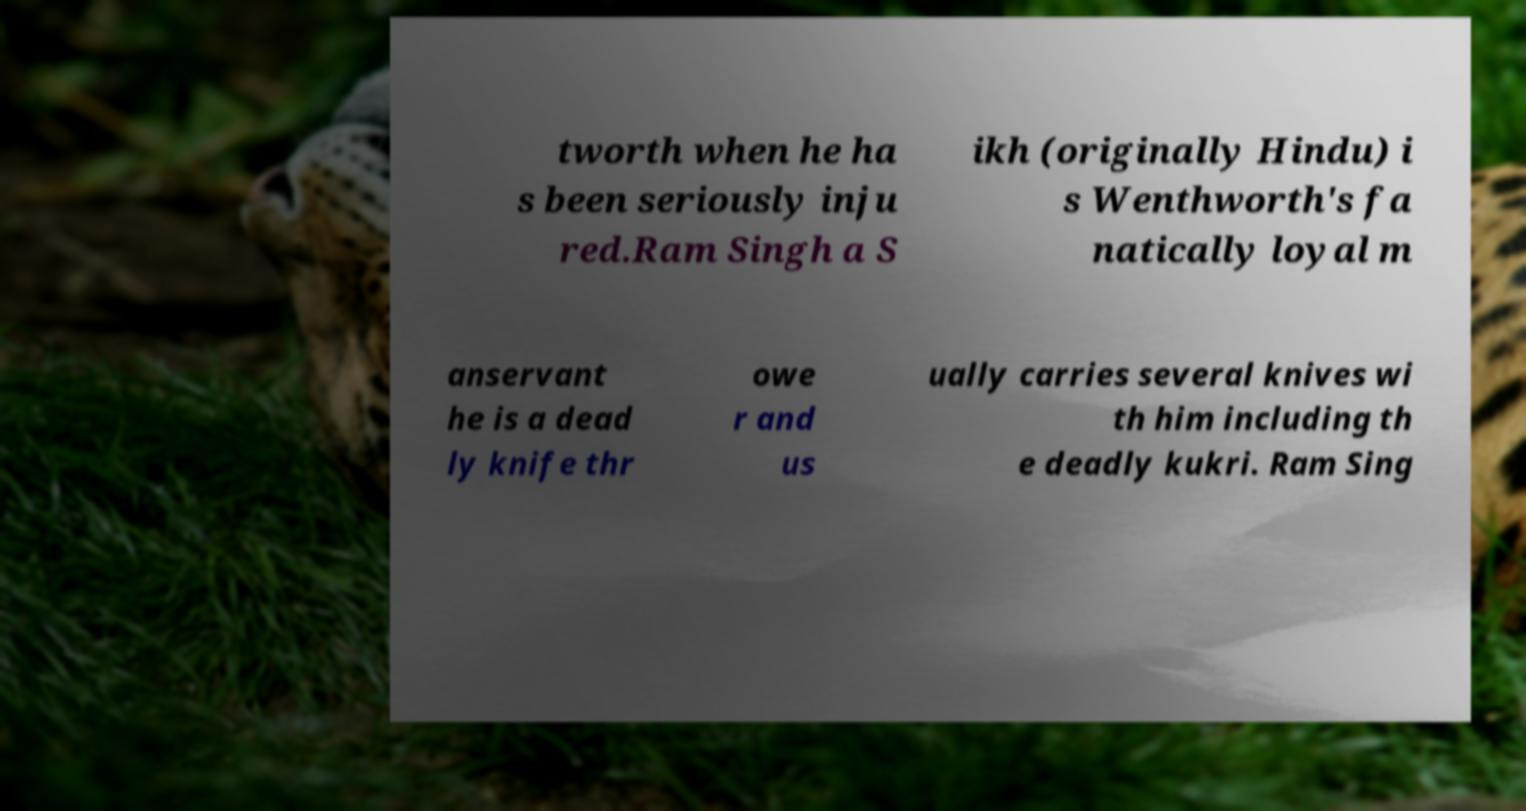For documentation purposes, I need the text within this image transcribed. Could you provide that? tworth when he ha s been seriously inju red.Ram Singh a S ikh (originally Hindu) i s Wenthworth's fa natically loyal m anservant he is a dead ly knife thr owe r and us ually carries several knives wi th him including th e deadly kukri. Ram Sing 